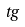Convert formula to latex. <formula><loc_0><loc_0><loc_500><loc_500>t g</formula> 